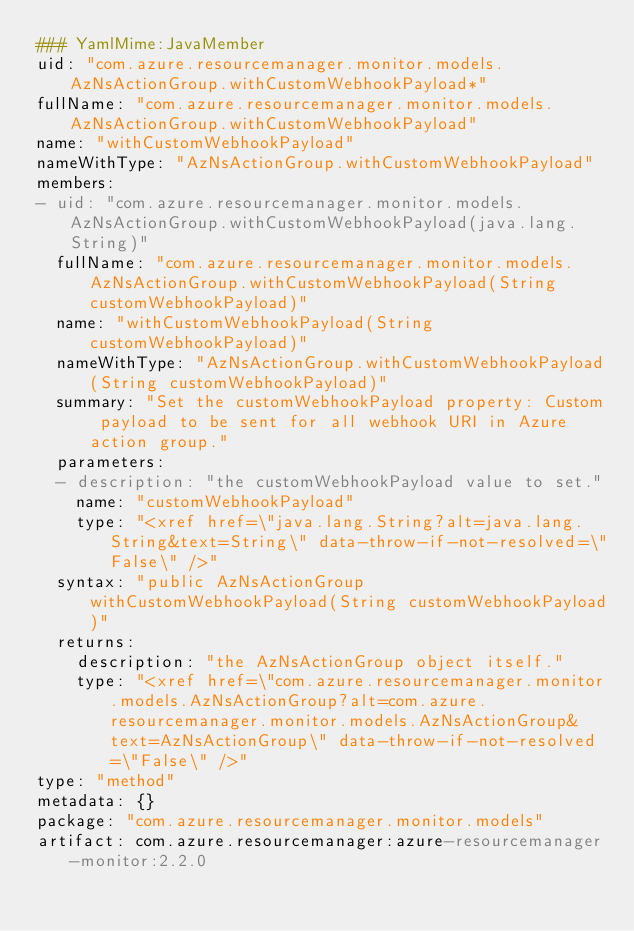<code> <loc_0><loc_0><loc_500><loc_500><_YAML_>### YamlMime:JavaMember
uid: "com.azure.resourcemanager.monitor.models.AzNsActionGroup.withCustomWebhookPayload*"
fullName: "com.azure.resourcemanager.monitor.models.AzNsActionGroup.withCustomWebhookPayload"
name: "withCustomWebhookPayload"
nameWithType: "AzNsActionGroup.withCustomWebhookPayload"
members:
- uid: "com.azure.resourcemanager.monitor.models.AzNsActionGroup.withCustomWebhookPayload(java.lang.String)"
  fullName: "com.azure.resourcemanager.monitor.models.AzNsActionGroup.withCustomWebhookPayload(String customWebhookPayload)"
  name: "withCustomWebhookPayload(String customWebhookPayload)"
  nameWithType: "AzNsActionGroup.withCustomWebhookPayload(String customWebhookPayload)"
  summary: "Set the customWebhookPayload property: Custom payload to be sent for all webhook URI in Azure action group."
  parameters:
  - description: "the customWebhookPayload value to set."
    name: "customWebhookPayload"
    type: "<xref href=\"java.lang.String?alt=java.lang.String&text=String\" data-throw-if-not-resolved=\"False\" />"
  syntax: "public AzNsActionGroup withCustomWebhookPayload(String customWebhookPayload)"
  returns:
    description: "the AzNsActionGroup object itself."
    type: "<xref href=\"com.azure.resourcemanager.monitor.models.AzNsActionGroup?alt=com.azure.resourcemanager.monitor.models.AzNsActionGroup&text=AzNsActionGroup\" data-throw-if-not-resolved=\"False\" />"
type: "method"
metadata: {}
package: "com.azure.resourcemanager.monitor.models"
artifact: com.azure.resourcemanager:azure-resourcemanager-monitor:2.2.0
</code> 